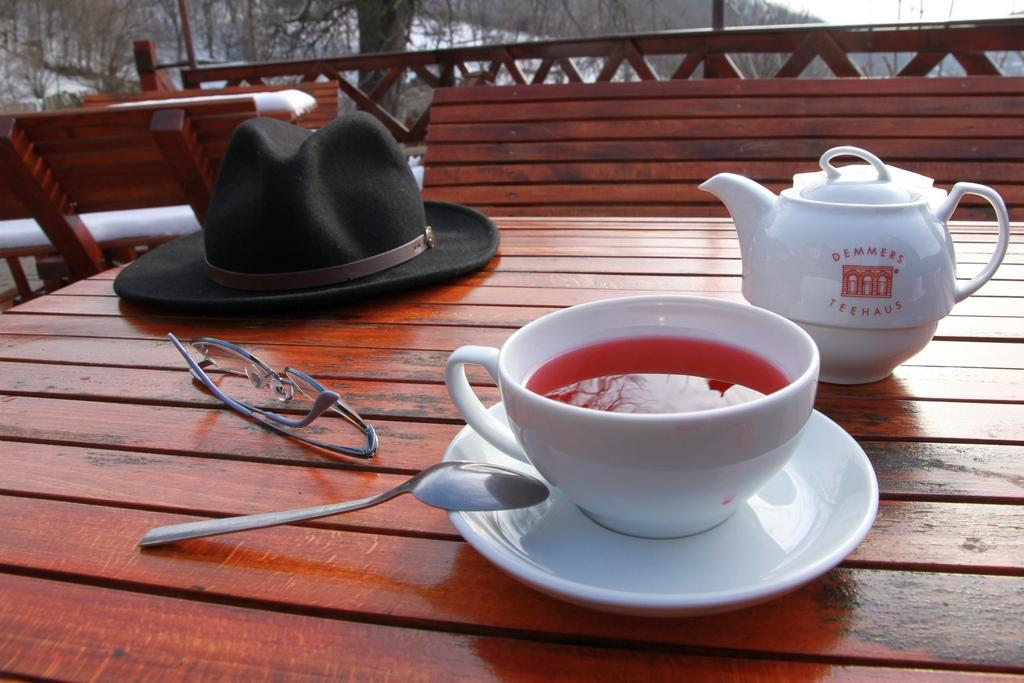What is the main piece of furniture in the image? There is a table in the image. What items can be seen on the table? There are glasses, a hat, cup and saucers, a mug, and a spoon on the table. What can be seen in the background of the image? There is a bench, railing, trees, sky, and snow visible in the background of the image. How many cows are visible in the image? There are no cows present in the image. What type of ball can be seen rolling on the table? There is no ball present on the table in the image. 